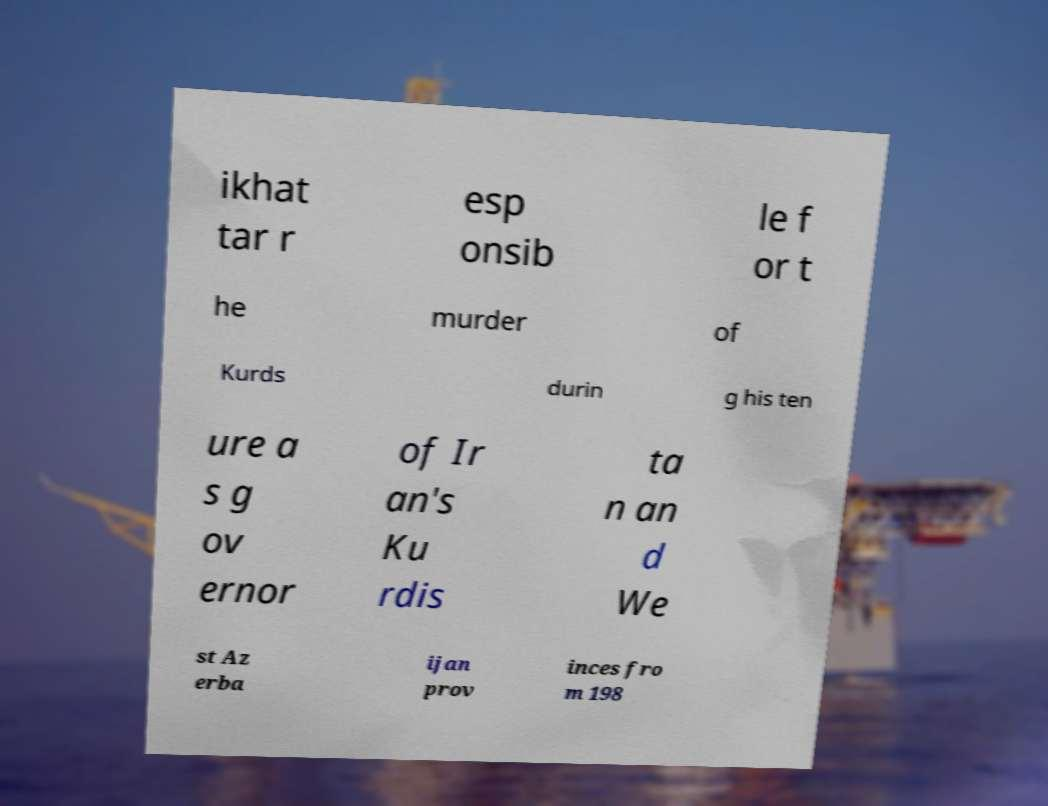I need the written content from this picture converted into text. Can you do that? ikhat tar r esp onsib le f or t he murder of Kurds durin g his ten ure a s g ov ernor of Ir an's Ku rdis ta n an d We st Az erba ijan prov inces fro m 198 